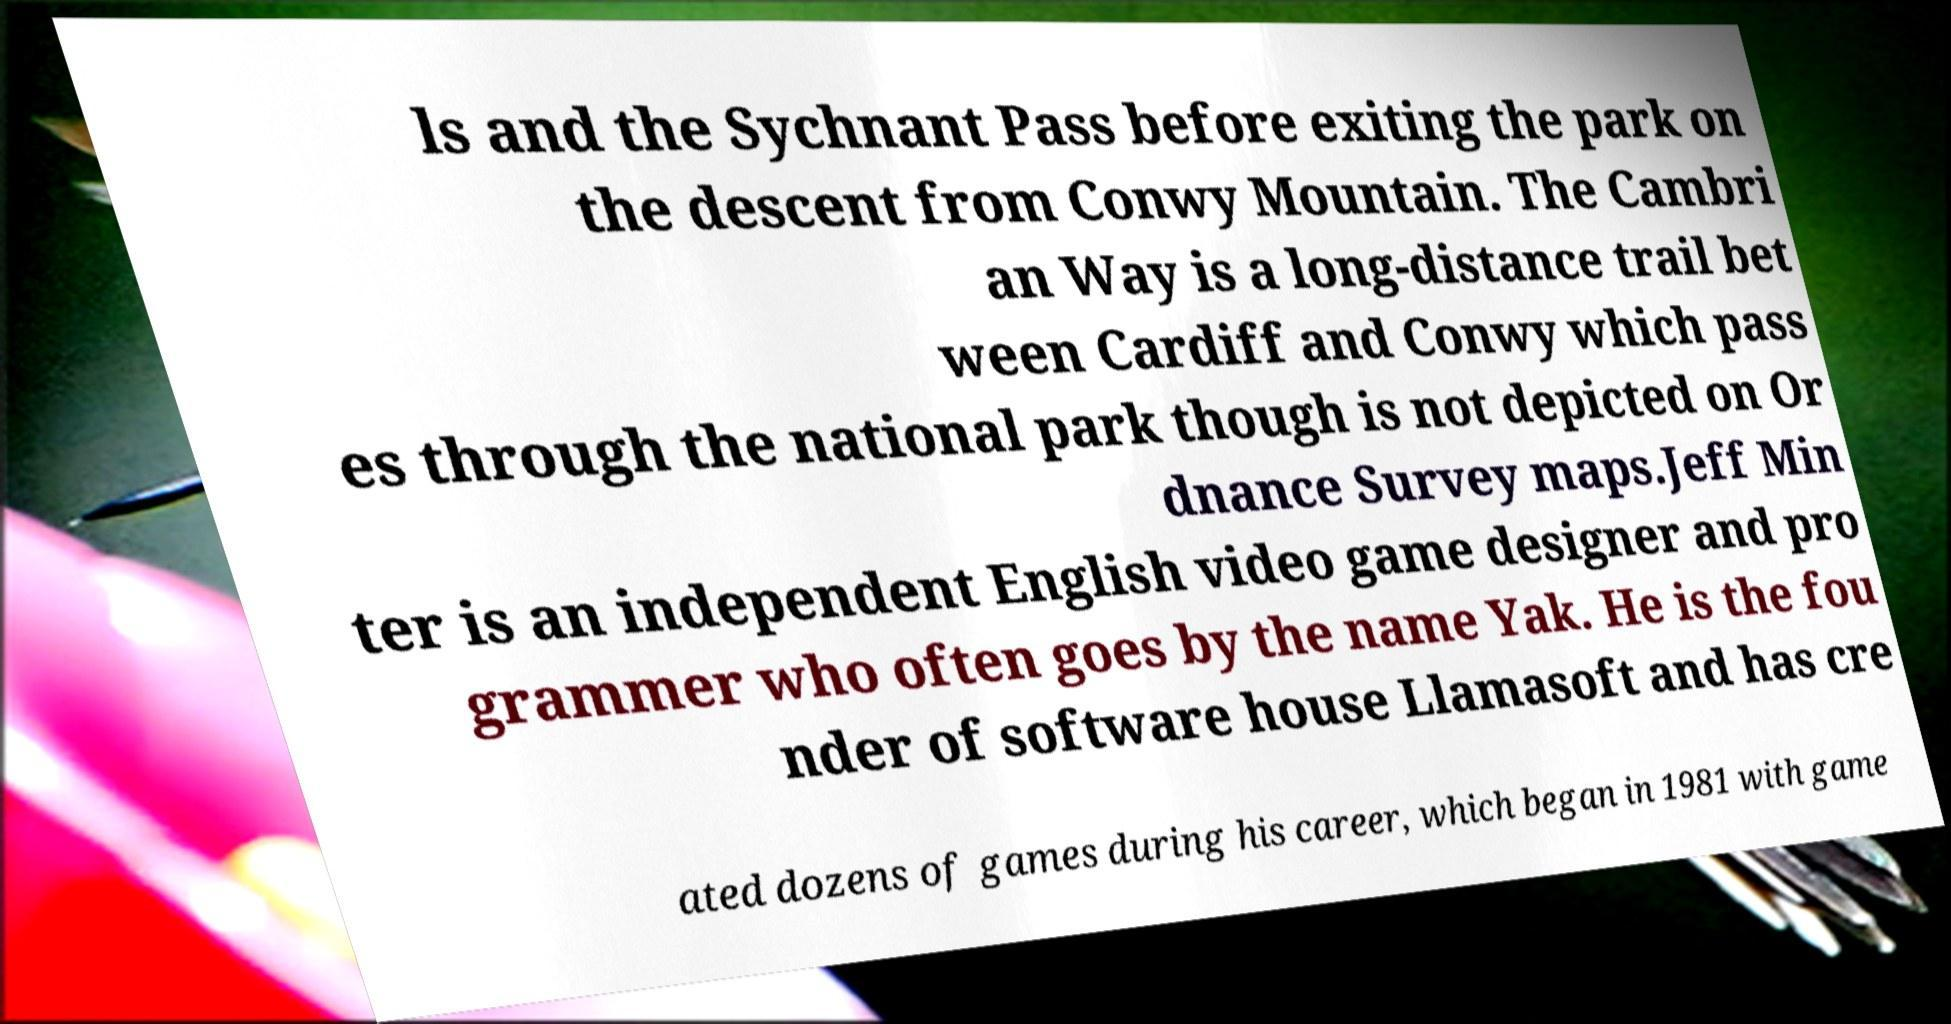Please read and relay the text visible in this image. What does it say? ls and the Sychnant Pass before exiting the park on the descent from Conwy Mountain. The Cambri an Way is a long-distance trail bet ween Cardiff and Conwy which pass es through the national park though is not depicted on Or dnance Survey maps.Jeff Min ter is an independent English video game designer and pro grammer who often goes by the name Yak. He is the fou nder of software house Llamasoft and has cre ated dozens of games during his career, which began in 1981 with game 